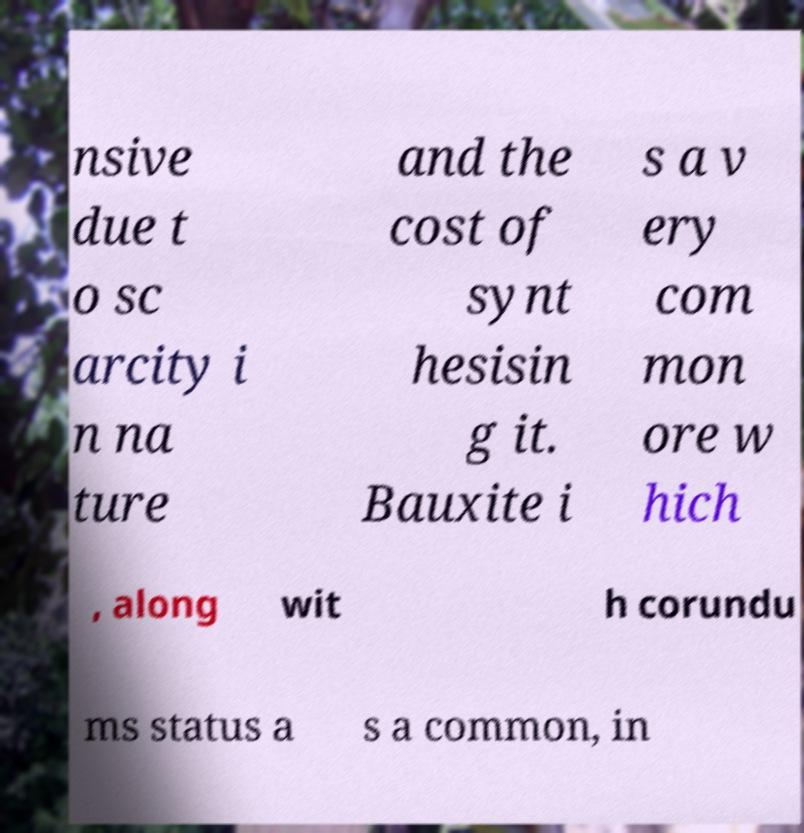Could you assist in decoding the text presented in this image and type it out clearly? nsive due t o sc arcity i n na ture and the cost of synt hesisin g it. Bauxite i s a v ery com mon ore w hich , along wit h corundu ms status a s a common, in 